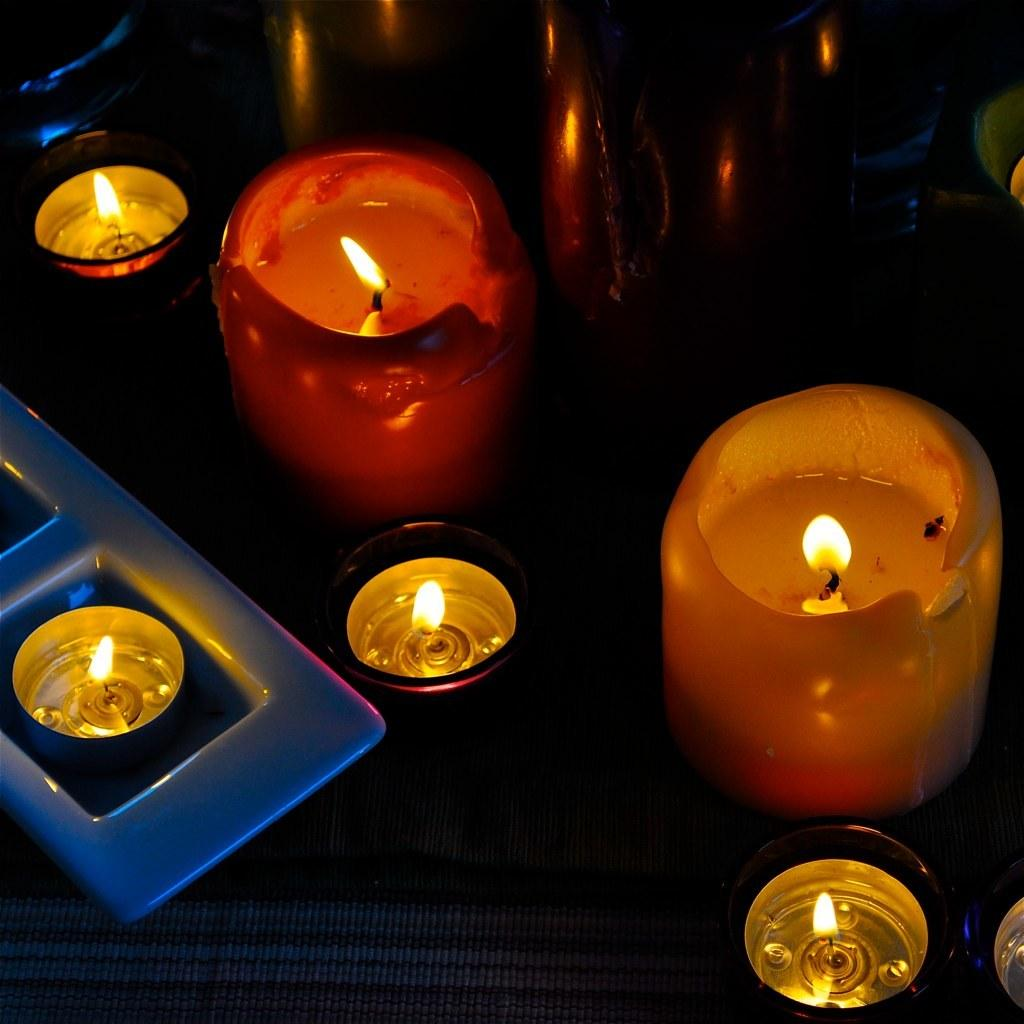What type of objects can be seen in the image? There are candles in the image. Can you describe the background of the image? There are objects in the background of the image. What type of drug is being discussed in the meeting in the image? There is no meeting or drug present in the image; it only features candles and objects in the background. 